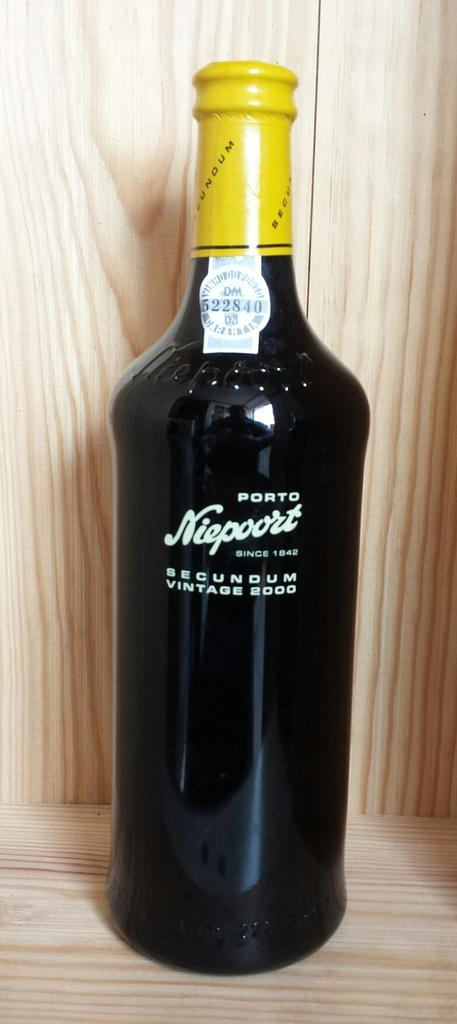Provide a one-sentence caption for the provided image. A bottle of Port Niepoort from 2000 has a bright yellow wrapper at the top. 